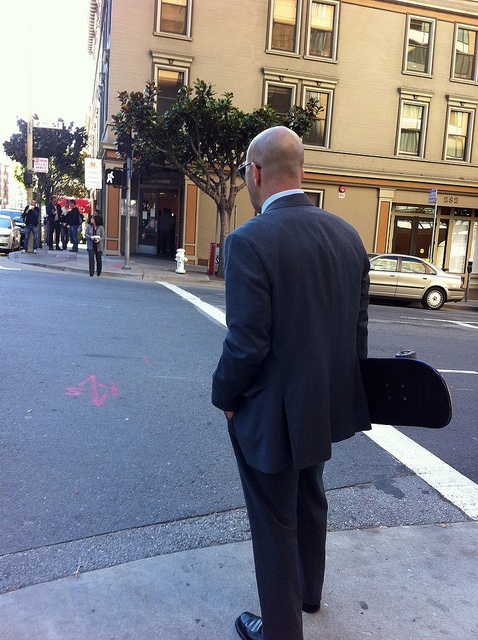Describe the objects in this image and their specific colors. I can see people in ivory, black, navy, and gray tones, skateboard in ivory, black, gray, and navy tones, car in ivory, tan, black, and darkgray tones, people in ivory, black, gray, and navy tones, and people in ivory, black, gray, and lightgray tones in this image. 